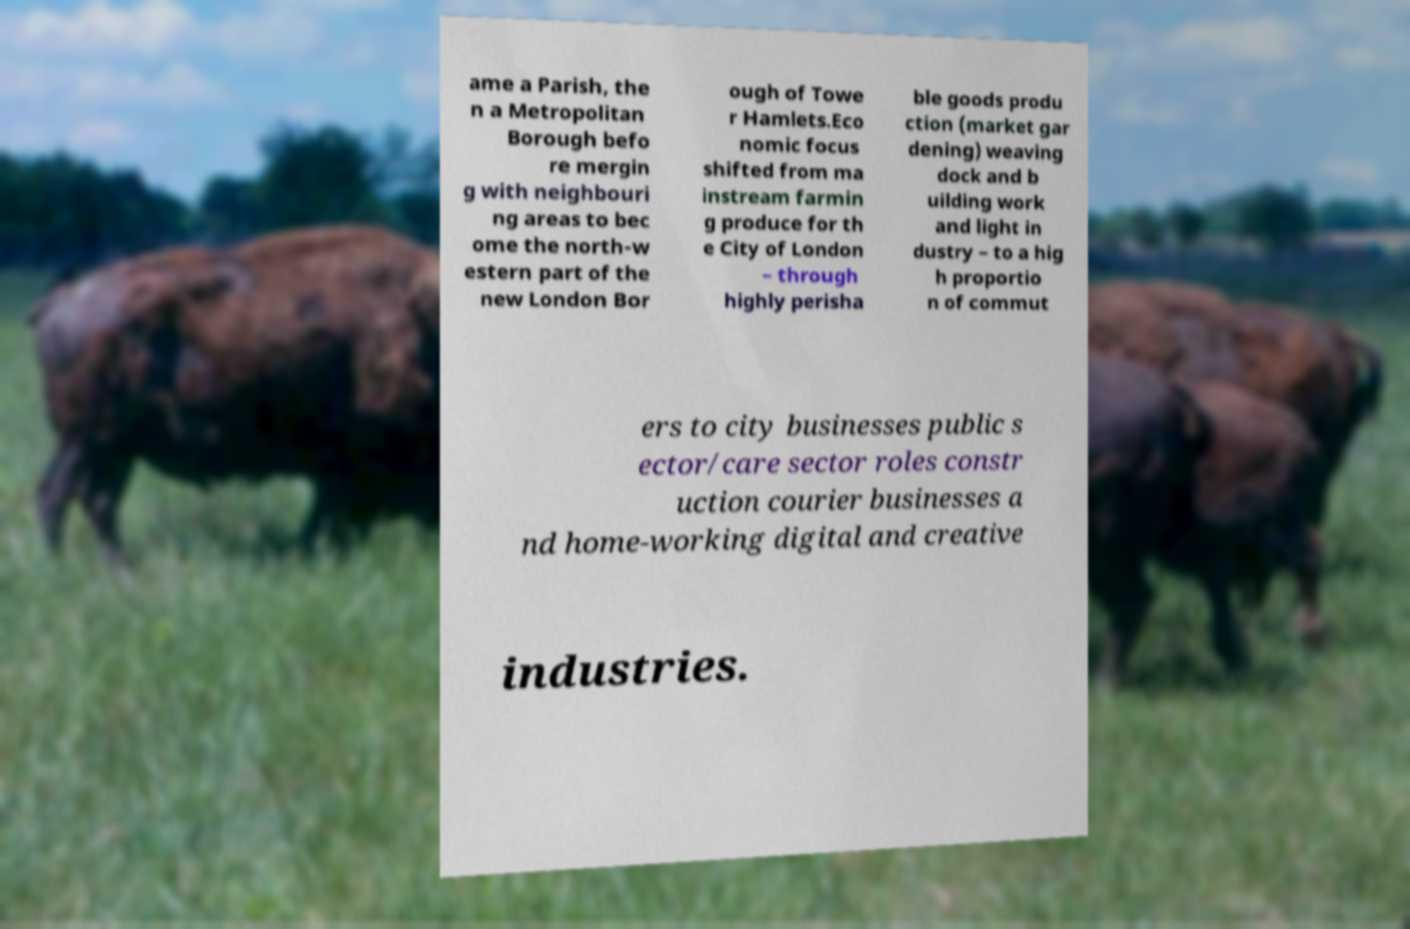Could you assist in decoding the text presented in this image and type it out clearly? ame a Parish, the n a Metropolitan Borough befo re mergin g with neighbouri ng areas to bec ome the north-w estern part of the new London Bor ough of Towe r Hamlets.Eco nomic focus shifted from ma instream farmin g produce for th e City of London – through highly perisha ble goods produ ction (market gar dening) weaving dock and b uilding work and light in dustry – to a hig h proportio n of commut ers to city businesses public s ector/care sector roles constr uction courier businesses a nd home-working digital and creative industries. 